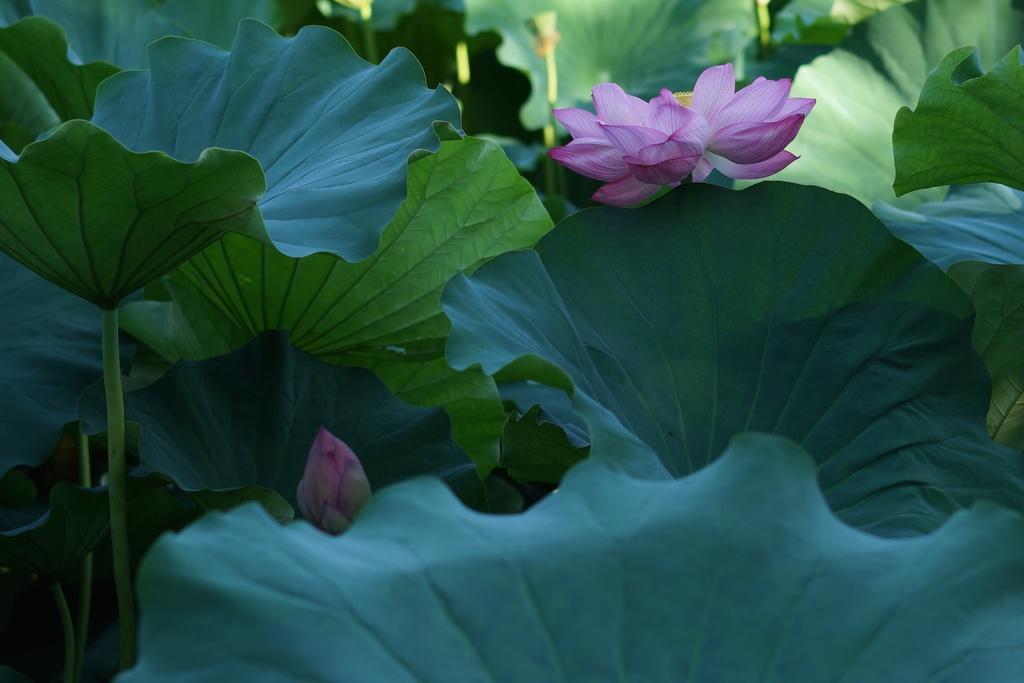Can you describe this image briefly? In this image I can see few leaves of the trees which are green in color and two flowers which are pink in color. 